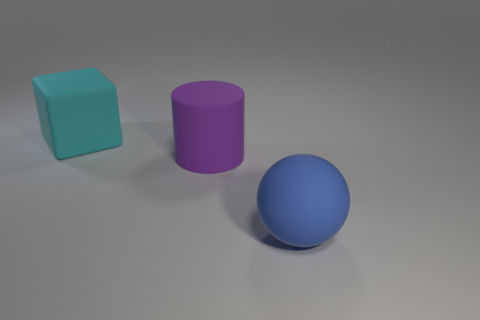Do the cyan block that is behind the cylinder and the large sphere have the same material? While the cyan block and the large sphere display different colors, it's impossible to determine whether they have the same material solely based on this image. They might have similar surface properties such as the degree of shininess or texture indicating close material characteristics. 